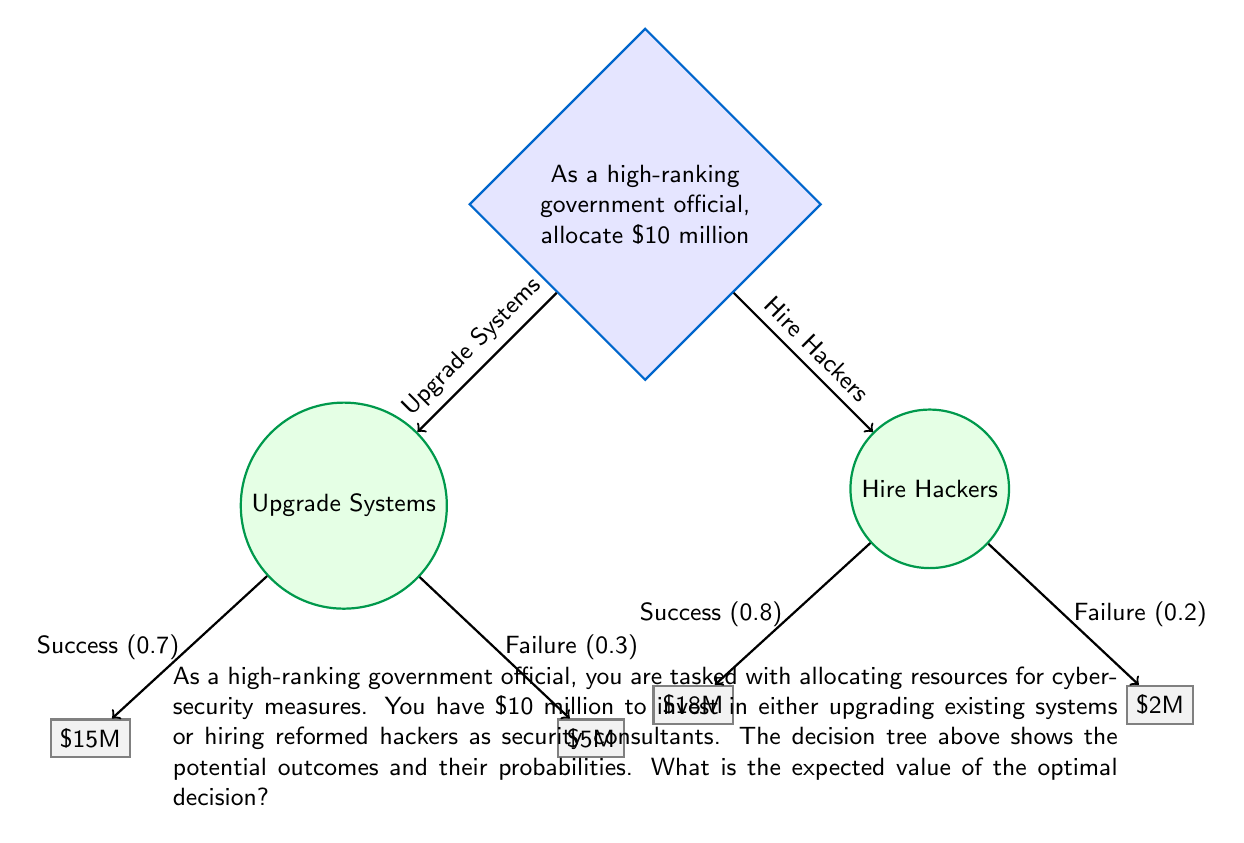Solve this math problem. To solve this problem, we'll use the concept of expected value in decision trees. We'll calculate the expected value for each decision and choose the one with the higher value.

1. Expected Value for Upgrading Systems:
   $$EV_{upgrade} = 0.7 \times \$15M + 0.3 \times \$5M$$
   $$EV_{upgrade} = \$10.5M + \$1.5M = \$12M$$

2. Expected Value for Hiring Hackers:
   $$EV_{hackers} = 0.8 \times \$18M + 0.2 \times \$2M$$
   $$EV_{hackers} = \$14.4M + \$0.4M = \$14.8M$$

3. Compare the two expected values:
   $EV_{hackers} > EV_{upgrade}$, so hiring hackers is the optimal decision.

4. The expected value of the optimal decision is $14.8 million.

This result suggests that hiring reformed hackers as security consultants is the better investment, with an expected return of $14.8 million compared to $12 million for upgrading existing systems. This aligns with the persona's belief in second chances and recognizing the value of the reformed hackers' skills.
Answer: The expected value of the optimal decision is $14.8 million. 